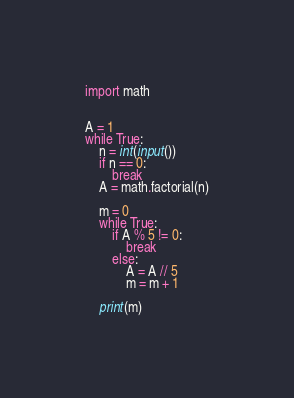<code> <loc_0><loc_0><loc_500><loc_500><_Python_>import math


A = 1
while True:
    n = int(input())
    if n == 0:
        break
    A = math.factorial(n)
    
    m = 0    
    while True:
        if A % 5 != 0:
            break
        else:
            A = A // 5
            m = m + 1
            
    print(m)

</code> 